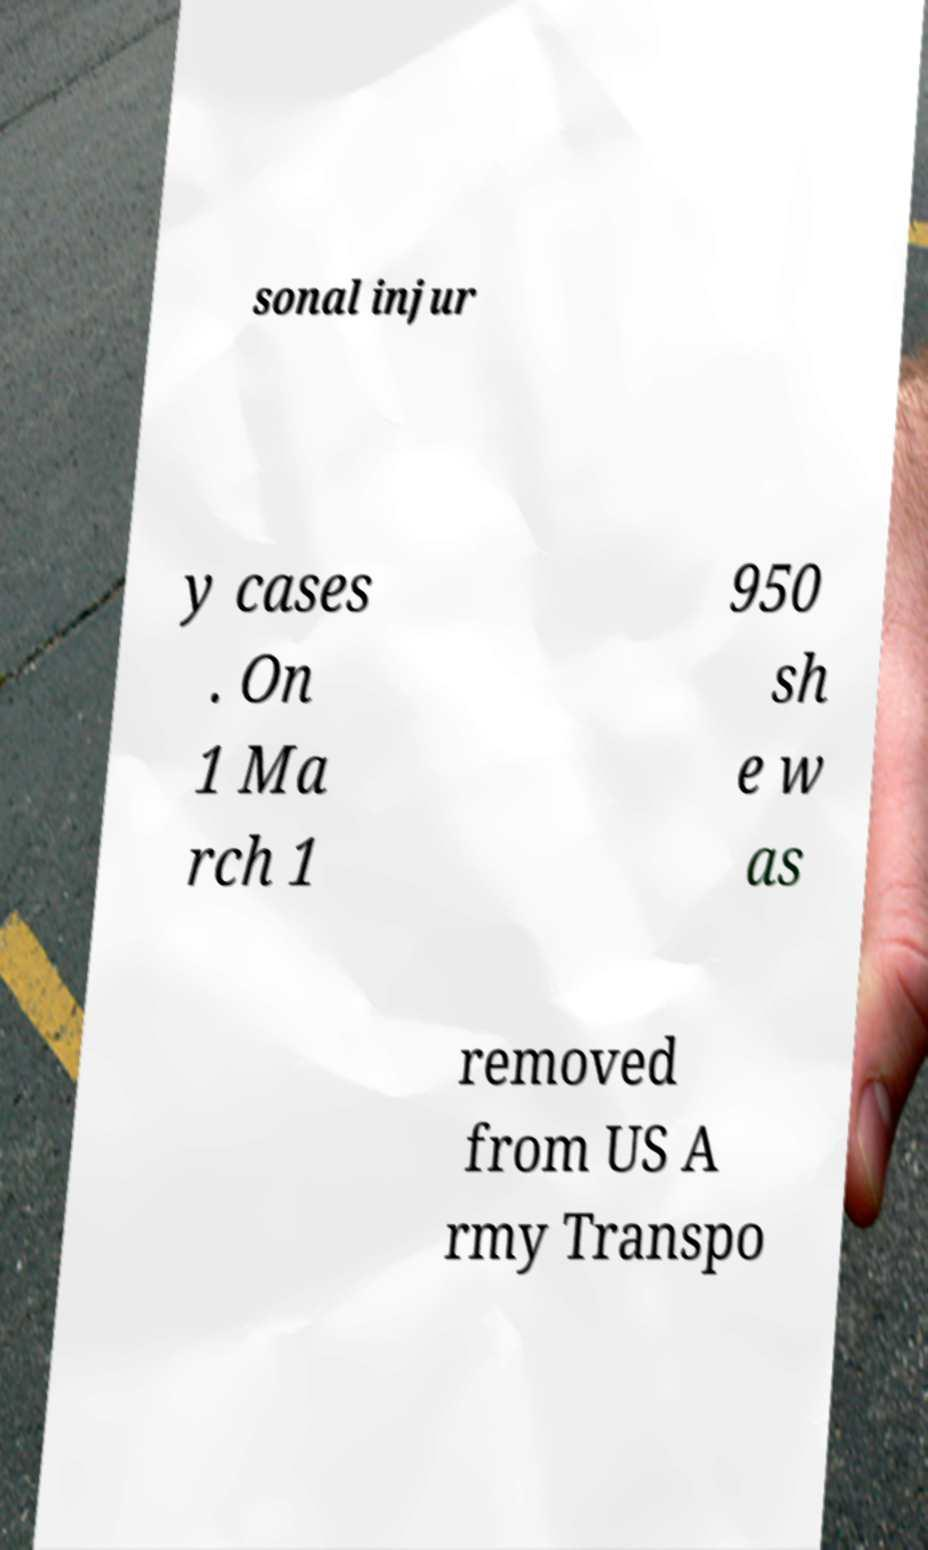There's text embedded in this image that I need extracted. Can you transcribe it verbatim? sonal injur y cases . On 1 Ma rch 1 950 sh e w as removed from US A rmy Transpo 